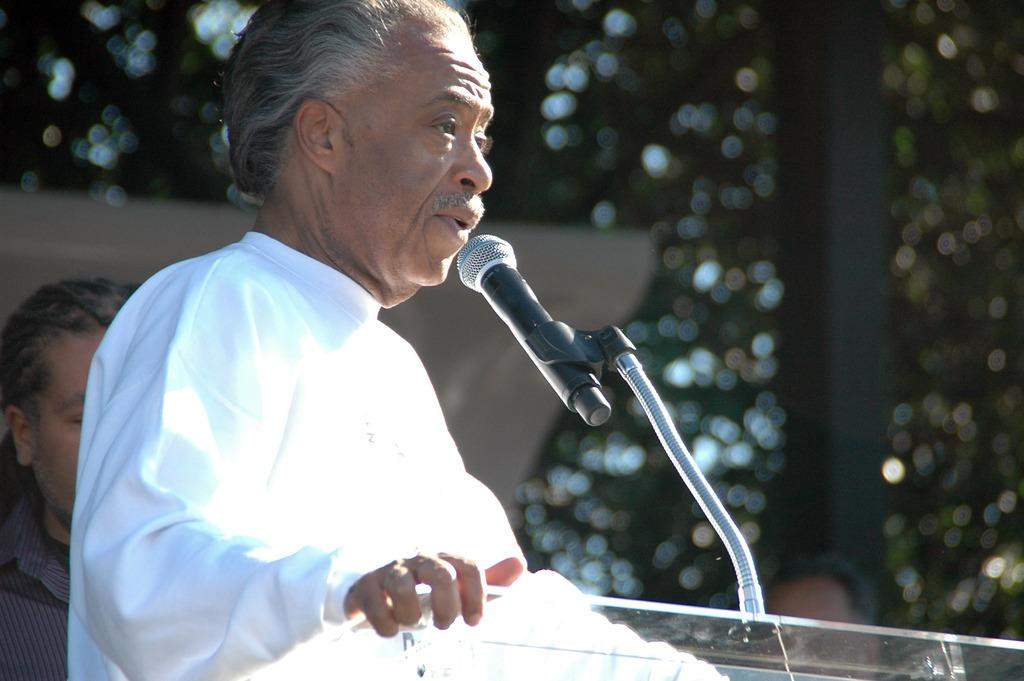Who is the main subject in the image? There is an old man in the image. What is the old man doing in the image? The old man is standing in front of a podium. What is the old man wearing in the image? The old man is wearing a white dress. What is on the podium that the old man is standing in front of? There is a mic on the podium. What can be seen in the background of the image? There are trees in the background of the image. Where is the cannon located in the image? There is no cannon present in the image. What type of clock is visible on the podium? There is no clock visible on the podium in the image. 